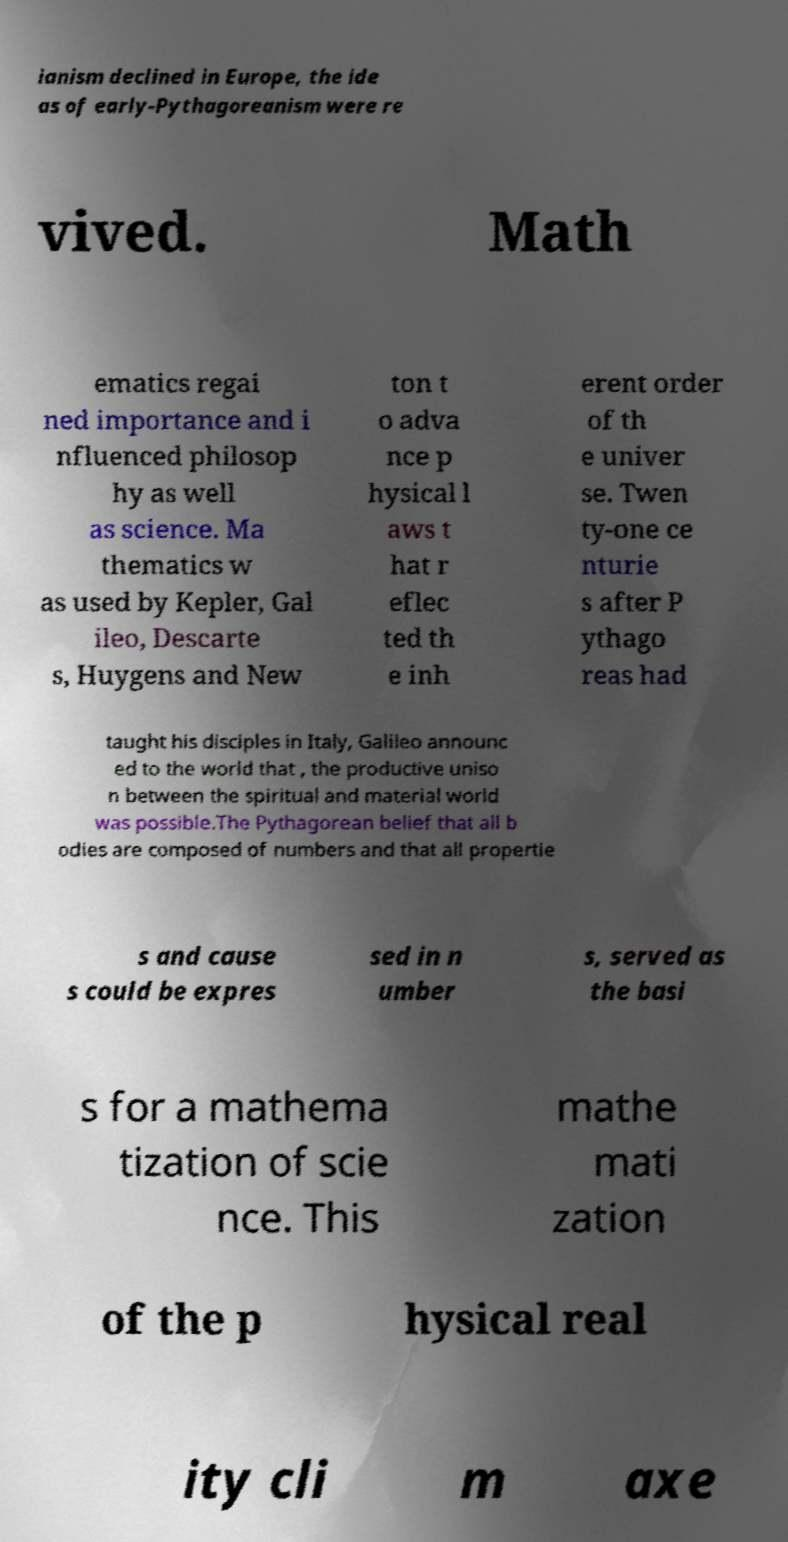Could you extract and type out the text from this image? ianism declined in Europe, the ide as of early-Pythagoreanism were re vived. Math ematics regai ned importance and i nfluenced philosop hy as well as science. Ma thematics w as used by Kepler, Gal ileo, Descarte s, Huygens and New ton t o adva nce p hysical l aws t hat r eflec ted th e inh erent order of th e univer se. Twen ty-one ce nturie s after P ythago reas had taught his disciples in Italy, Galileo announc ed to the world that , the productive uniso n between the spiritual and material world was possible.The Pythagorean belief that all b odies are composed of numbers and that all propertie s and cause s could be expres sed in n umber s, served as the basi s for a mathema tization of scie nce. This mathe mati zation of the p hysical real ity cli m axe 